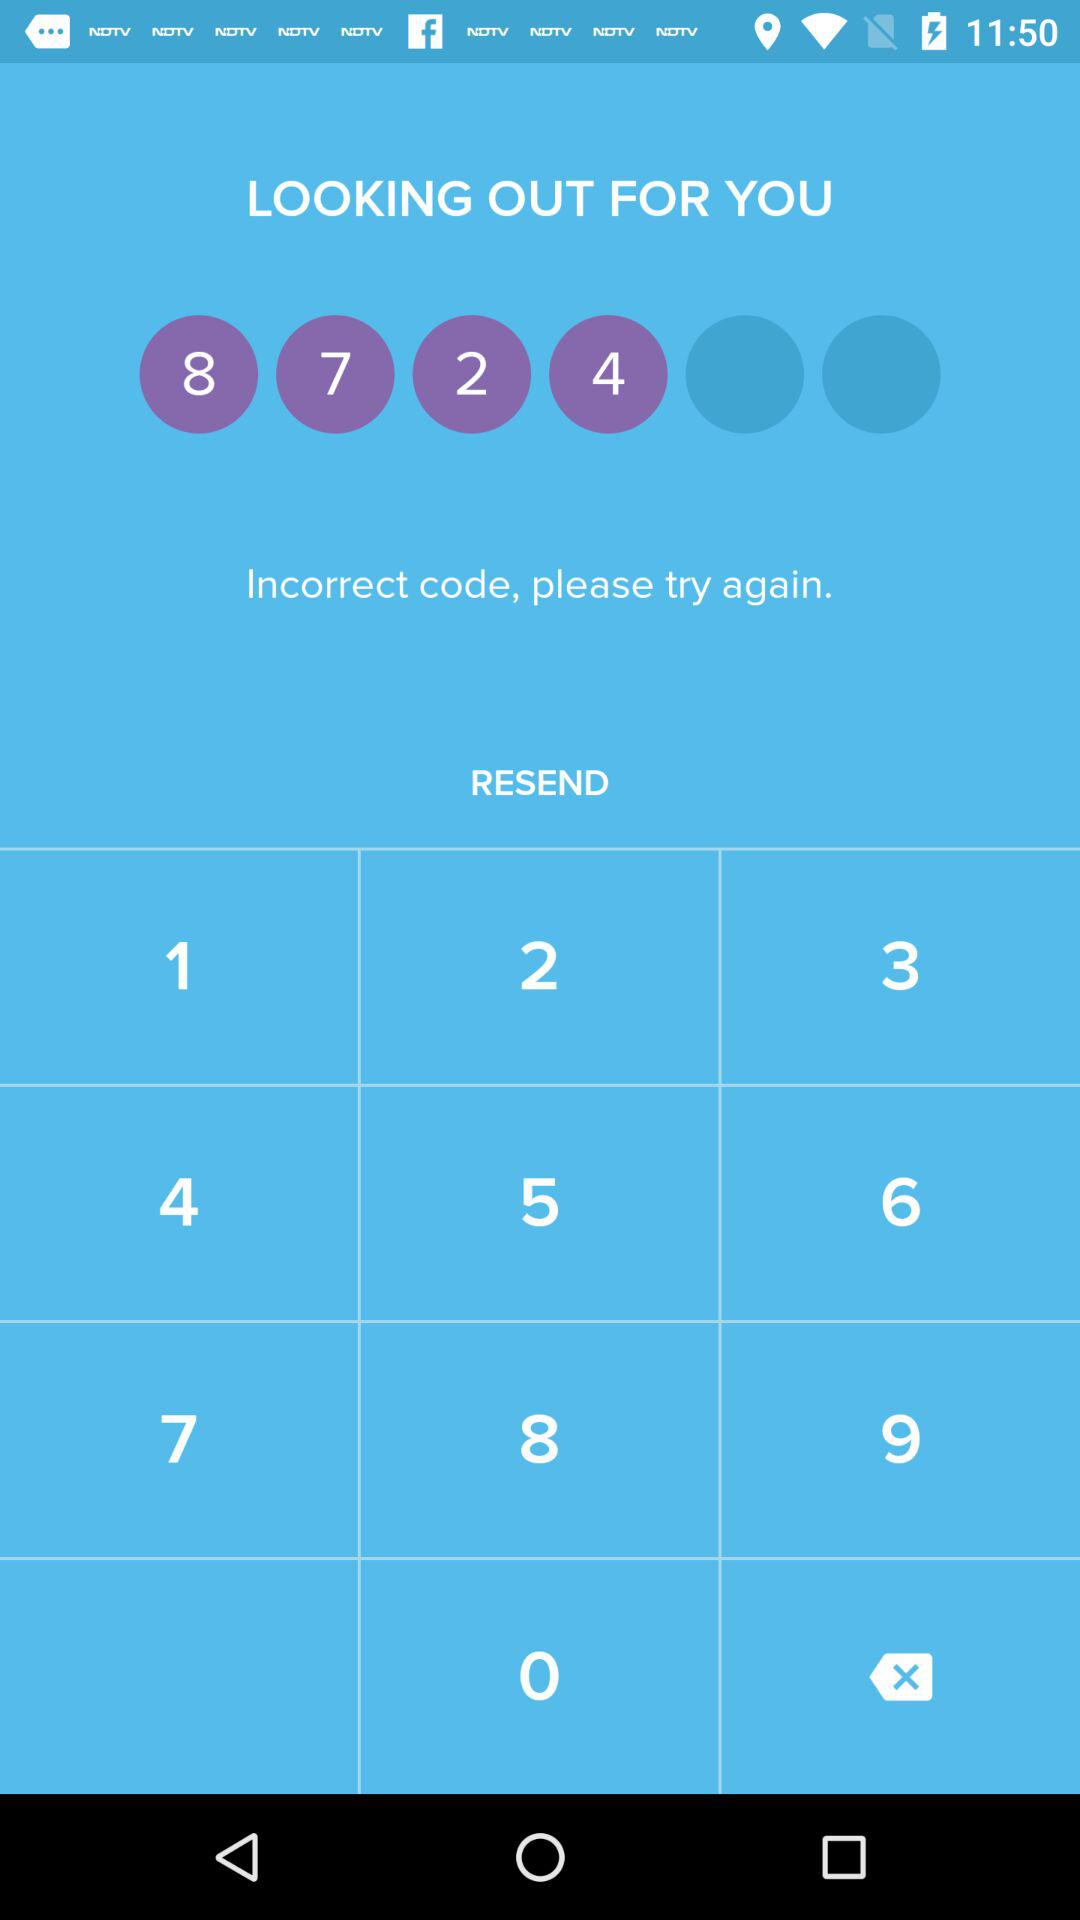How many numbers are there in the text input?
Answer the question using a single word or phrase. 4 